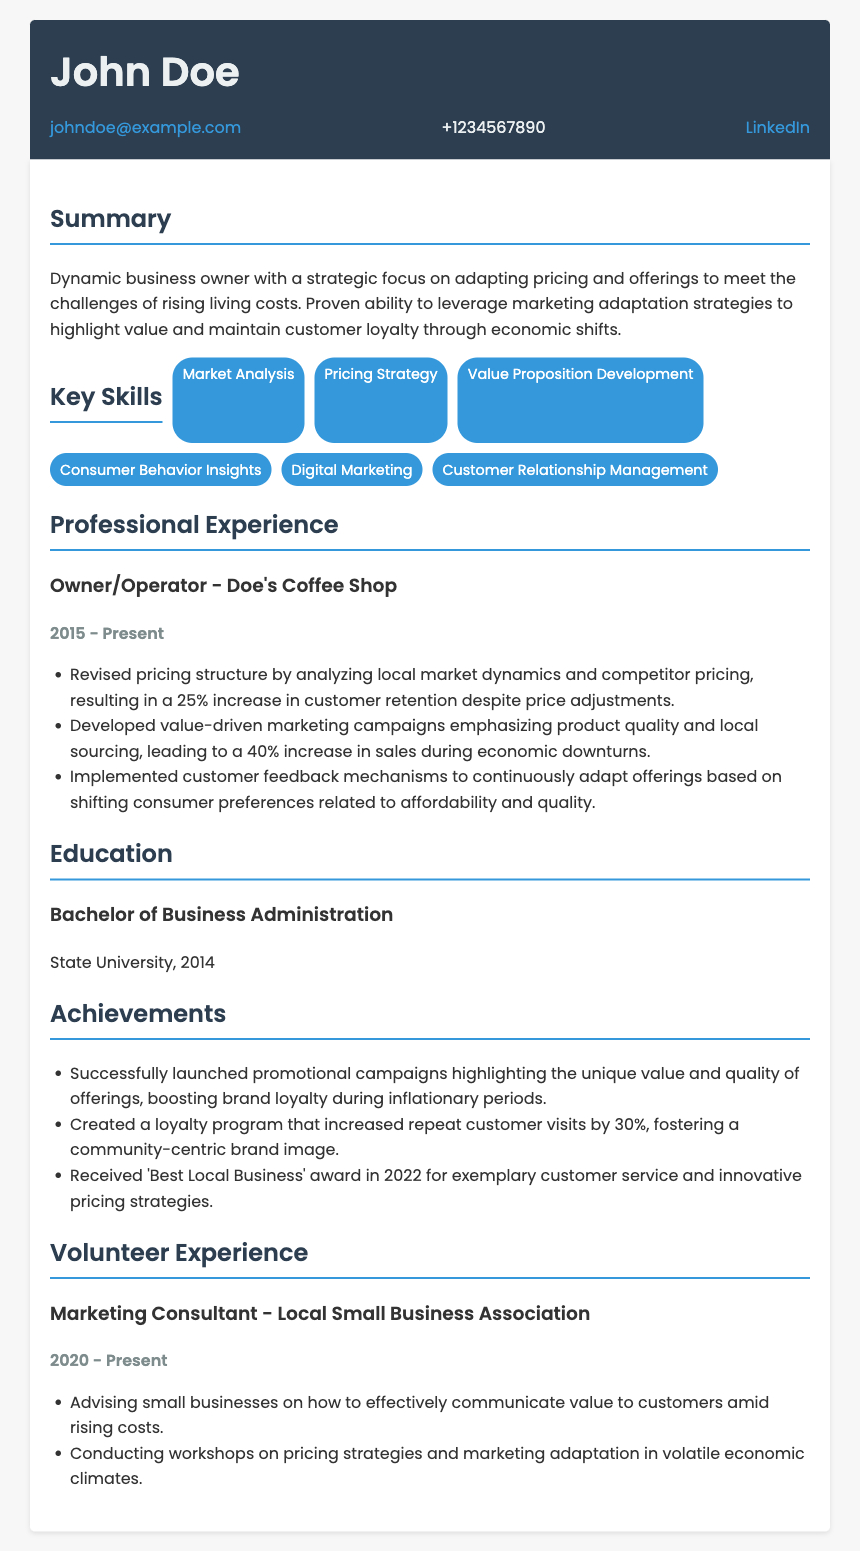what is the name of the business owner? The name of the business owner is mentioned at the top of the document.
Answer: John Doe what is the email address provided? The email address is listed in the contact information section.
Answer: johndoe@example.com what is the total increase in customer retention after revising the pricing structure? The percentage increase in customer retention can be found in the experience section.
Answer: 25% what year did the business owner complete their degree? The year of graduation is specified under the education section.
Answer: 2014 how much did sales increase during economic downturns due to marketing campaigns? The percentage increase in sales from the campaigns is described in the experience section.
Answer: 40% what award did the business owner receive in 2022? The document mentions accolades the owner received within the achievements section.
Answer: Best Local Business how long has the business owner been operating Doe's Coffee Shop? The duration of the business operation can be determined from the experience section.
Answer: 8 years which skill is related to understanding consumer preferences? The relevant skill corresponding to consumer preferences is listed in the key skills section.
Answer: Consumer Behavior Insights what role does the business owner have in the Local Small Business Association? The specific position held within the association is stated in the volunteer experience section.
Answer: Marketing Consultant 